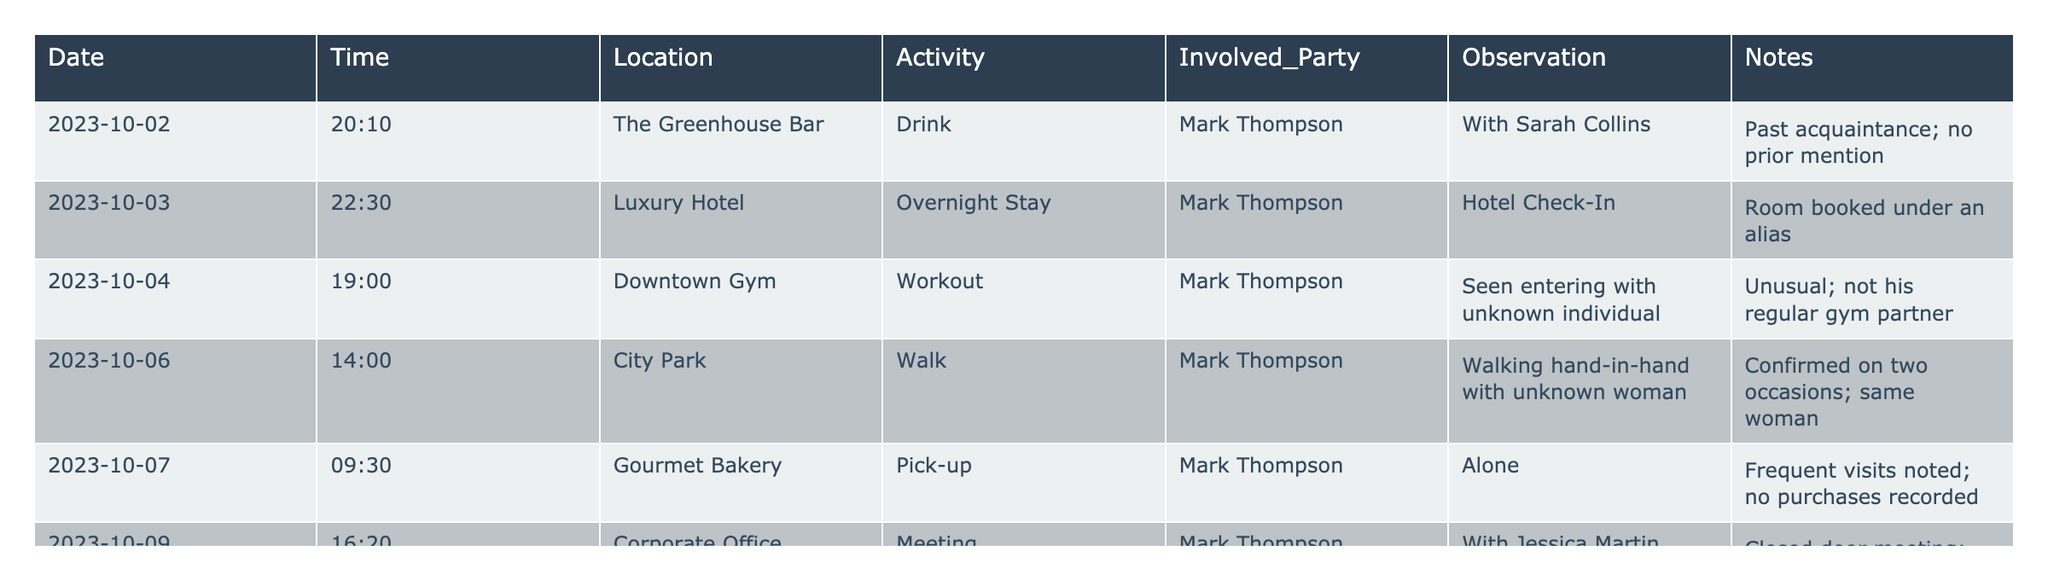What date did Mark Thompson stay overnight at the Luxury Hotel? The data shows that Mark Thompson had an overnight stay at the Luxury Hotel on 2023-10-03, which is indicated in the corresponding row.
Answer: 2023-10-03 How many times was Mark Thompson seen with an unknown woman? Mark Thompson was observed walking hand-in-hand with an unknown woman on two occasions, as noted in the entry for City Park on 2023-10-06.
Answer: 2 times Did Mark Thompson purchase anything during his visit to the Gourmet Bakery? According to the observation for the Gourmet Bakery, it states that Mark Thompson was alone and no purchases were recorded.
Answer: No What was the unusual observation noted at Downtown Gym? The table indicates that Mark Thompson was seen entering the Downtown Gym with an unknown individual, which is unusual because it mentions that this is not his regular gym partner.
Answer: Entering with an unknown individual How many activities involve Mark Thompson staying at a location for more than 2 hours? To assess this, we check the observations: Overnight stay at the Luxury Hotel on 2023-10-03 is more than 2 hours, as is the closed-door meeting at the Corporate Office on 2023-10-09, which had a duration longer than usual, indicating both count as staying longer. Thus, there are 2 activities.
Answer: 2 activities Was there any meeting on 2023-10-09? The entry for this date confirms that Mark Thompson had a meeting at the Corporate Office, specifically noted as being with Jessica Martin.
Answer: Yes What location had multiple confirmations of Mark Thompson with the same woman? The City Park entry states that he was walking hand-in-hand with the same unknown woman, confirming this activity on two different occasions.
Answer: City Park Calculate the total number of unique locations where Mark Thompson was observed. By reviewing each location in the table, we identify six unique locations: The Greenhouse Bar, Luxury Hotel, Downtown Gym, City Park, Gourmet Bakery, and Corporate Office. Therefore, the total is 6.
Answer: 6 locations On which date did Mark Thompson visit The Greenhouse Bar? The table shows that Mark Thompson visited The Greenhouse Bar on 2023-10-02, as indicated in the corresponding entry.
Answer: 2023-10-02 